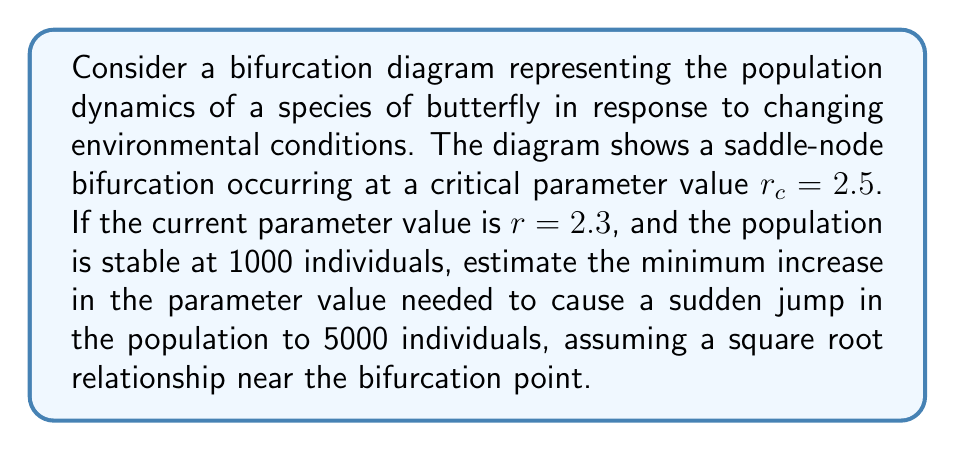Could you help me with this problem? To solve this problem, we'll follow these steps:

1) In a saddle-node bifurcation, the relationship between the state variable (population) and the bifurcation parameter near the critical point is given by:

   $$x \propto \sqrt{r - r_c}$$

   where $x$ is the difference between the current state and the state at the bifurcation point.

2) We need to find the change in $r$, let's call it $\Delta r$, that causes the population to jump from 1000 to 5000.

3) At the current state:
   $$\sqrt{2.3 - 2.5} \propto 1000 - x_0$$
   where $x_0$ is the population at the bifurcation point.

4) At the jumped state:
   $$\sqrt{(2.3 + \Delta r) - 2.5} \propto 5000 - x_0$$

5) Dividing these equations:

   $$\frac{\sqrt{2.3 + \Delta r - 2.5}}{\sqrt{2.3 - 2.5}} = \frac{5000 - x_0}{1000 - x_0}$$

6) Simplifying:

   $$\sqrt{\frac{-0.2 + \Delta r}{-0.2}} = 5$$

7) Solving for $\Delta r$:

   $$\frac{-0.2 + \Delta r}{-0.2} = 25$$
   $$-0.2 + \Delta r = -5$$
   $$\Delta r = -4.8$$

8) Therefore, the minimum increase in the parameter value is 0.2.

This solution provides an estimate based on the simplified square root relationship near the bifurcation point, which is suitable for macro-level analysis of population dynamics in insect behavior.
Answer: 0.2 